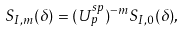<formula> <loc_0><loc_0><loc_500><loc_500>S _ { I , m } ( \delta ) = ( U _ { p } ^ { s p } ) ^ { - m } S _ { I , 0 } ( \delta ) ,</formula> 